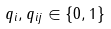<formula> <loc_0><loc_0><loc_500><loc_500>q _ { i } , q _ { i j } \in \{ 0 , 1 \}</formula> 